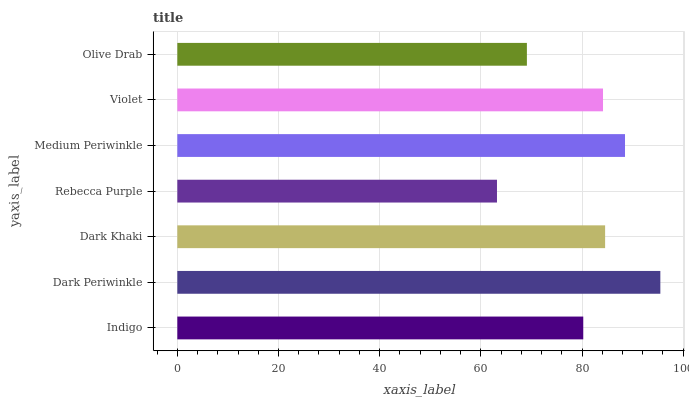Is Rebecca Purple the minimum?
Answer yes or no. Yes. Is Dark Periwinkle the maximum?
Answer yes or no. Yes. Is Dark Khaki the minimum?
Answer yes or no. No. Is Dark Khaki the maximum?
Answer yes or no. No. Is Dark Periwinkle greater than Dark Khaki?
Answer yes or no. Yes. Is Dark Khaki less than Dark Periwinkle?
Answer yes or no. Yes. Is Dark Khaki greater than Dark Periwinkle?
Answer yes or no. No. Is Dark Periwinkle less than Dark Khaki?
Answer yes or no. No. Is Violet the high median?
Answer yes or no. Yes. Is Violet the low median?
Answer yes or no. Yes. Is Dark Khaki the high median?
Answer yes or no. No. Is Medium Periwinkle the low median?
Answer yes or no. No. 